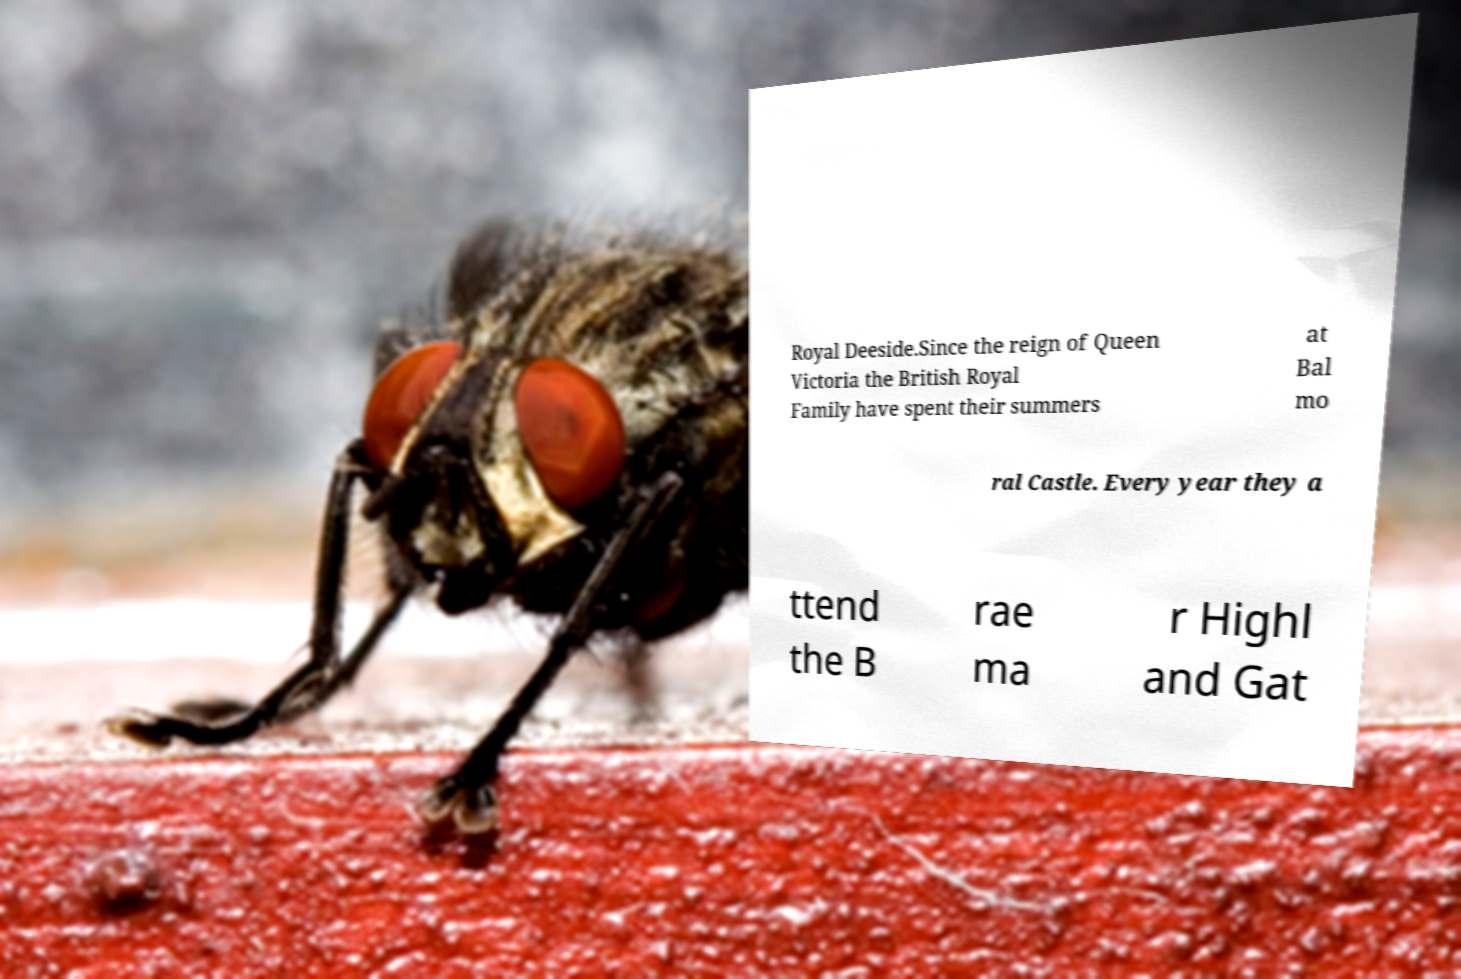Can you accurately transcribe the text from the provided image for me? Royal Deeside.Since the reign of Queen Victoria the British Royal Family have spent their summers at Bal mo ral Castle. Every year they a ttend the B rae ma r Highl and Gat 